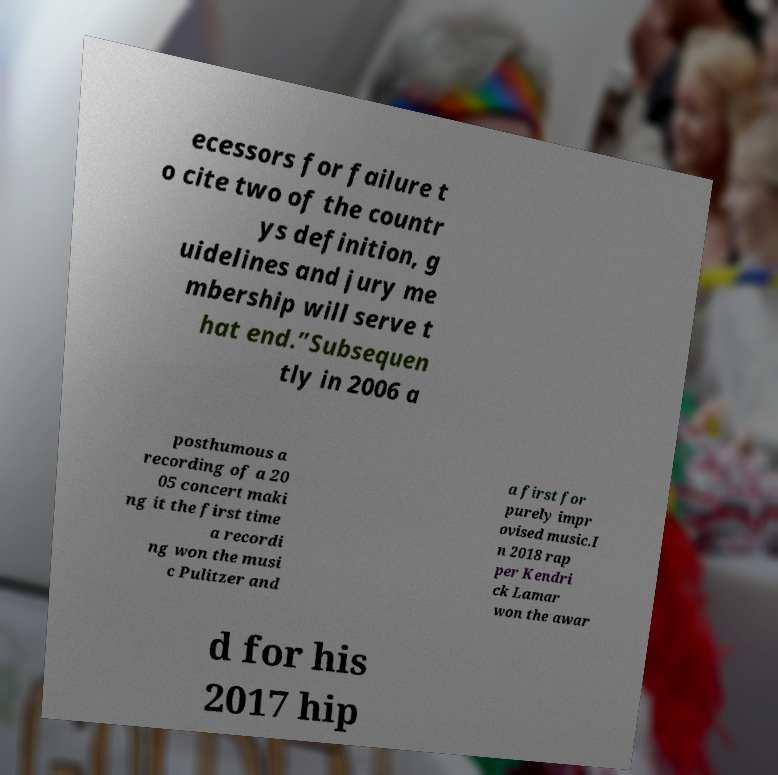Could you assist in decoding the text presented in this image and type it out clearly? ecessors for failure t o cite two of the countr ys definition, g uidelines and jury me mbership will serve t hat end.”Subsequen tly in 2006 a posthumous a recording of a 20 05 concert maki ng it the first time a recordi ng won the musi c Pulitzer and a first for purely impr ovised music.I n 2018 rap per Kendri ck Lamar won the awar d for his 2017 hip 